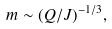Convert formula to latex. <formula><loc_0><loc_0><loc_500><loc_500>m \sim ( Q / J ) ^ { - 1 / 3 } ,</formula> 